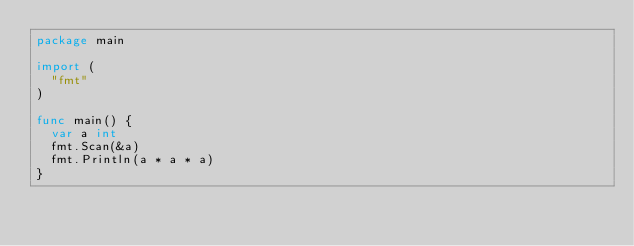<code> <loc_0><loc_0><loc_500><loc_500><_Go_>package main

import (
	"fmt"
)

func main() {
	var a int
	fmt.Scan(&a)
	fmt.Println(a * a * a)
}
</code> 